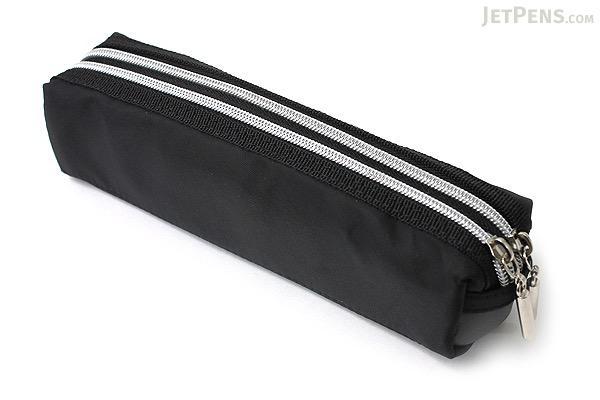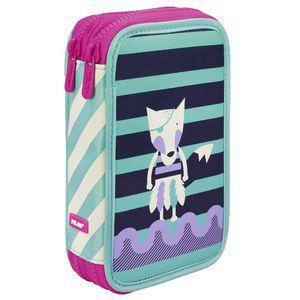The first image is the image on the left, the second image is the image on the right. For the images shown, is this caption "One image contains a closed red zippered case without any writing implements near it." true? Answer yes or no. No. The first image is the image on the left, the second image is the image on the right. Analyze the images presented: Is the assertion "The right image contains a small red hand bag." valid? Answer yes or no. No. 